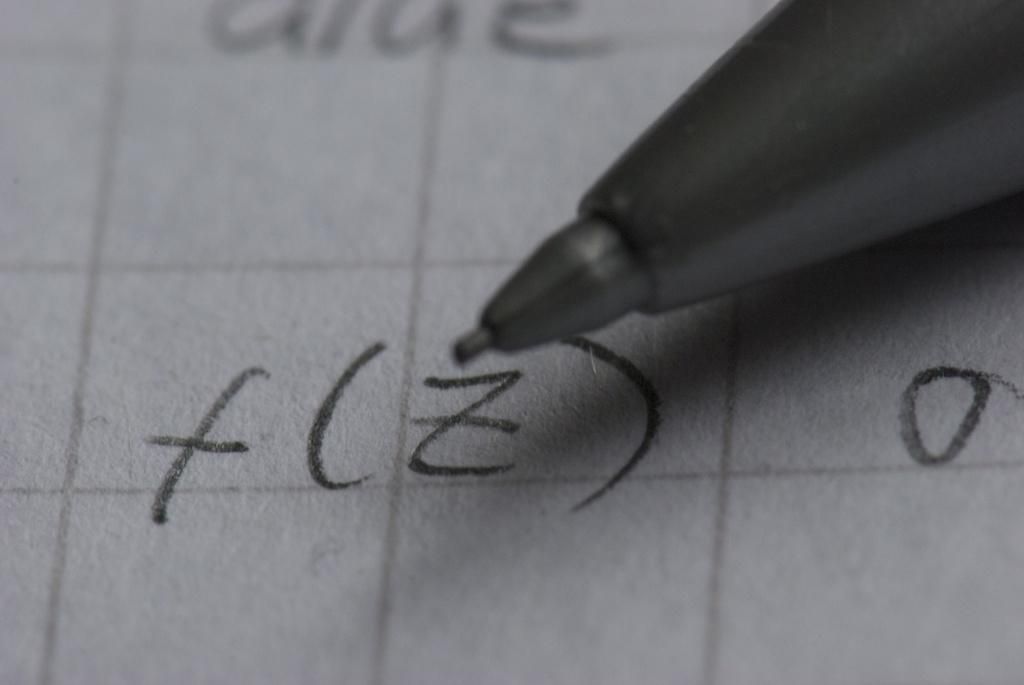What type of writing instrument is visible in the image? There is a click pencil in the image. What can be seen on the surface in the image? There is text on a surface in the image. What type of tooth is visible in the image? There is no tooth present in the image. How does the umbrella provide a sense of protection in the image? There is no umbrella present in the image, so it cannot provide any sense of protection. 